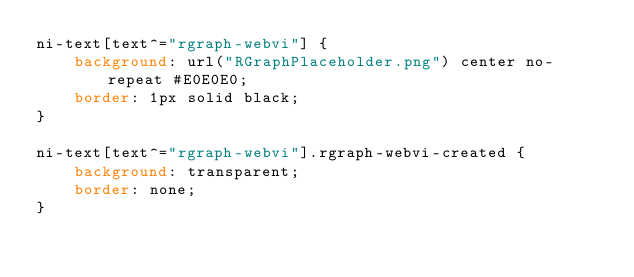Convert code to text. <code><loc_0><loc_0><loc_500><loc_500><_CSS_>ni-text[text^="rgraph-webvi"] {
    background: url("RGraphPlaceholder.png") center no-repeat #E0E0E0;
    border: 1px solid black;
}

ni-text[text^="rgraph-webvi"].rgraph-webvi-created {
    background: transparent;
    border: none;
}
</code> 